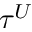Convert formula to latex. <formula><loc_0><loc_0><loc_500><loc_500>\tau ^ { U }</formula> 